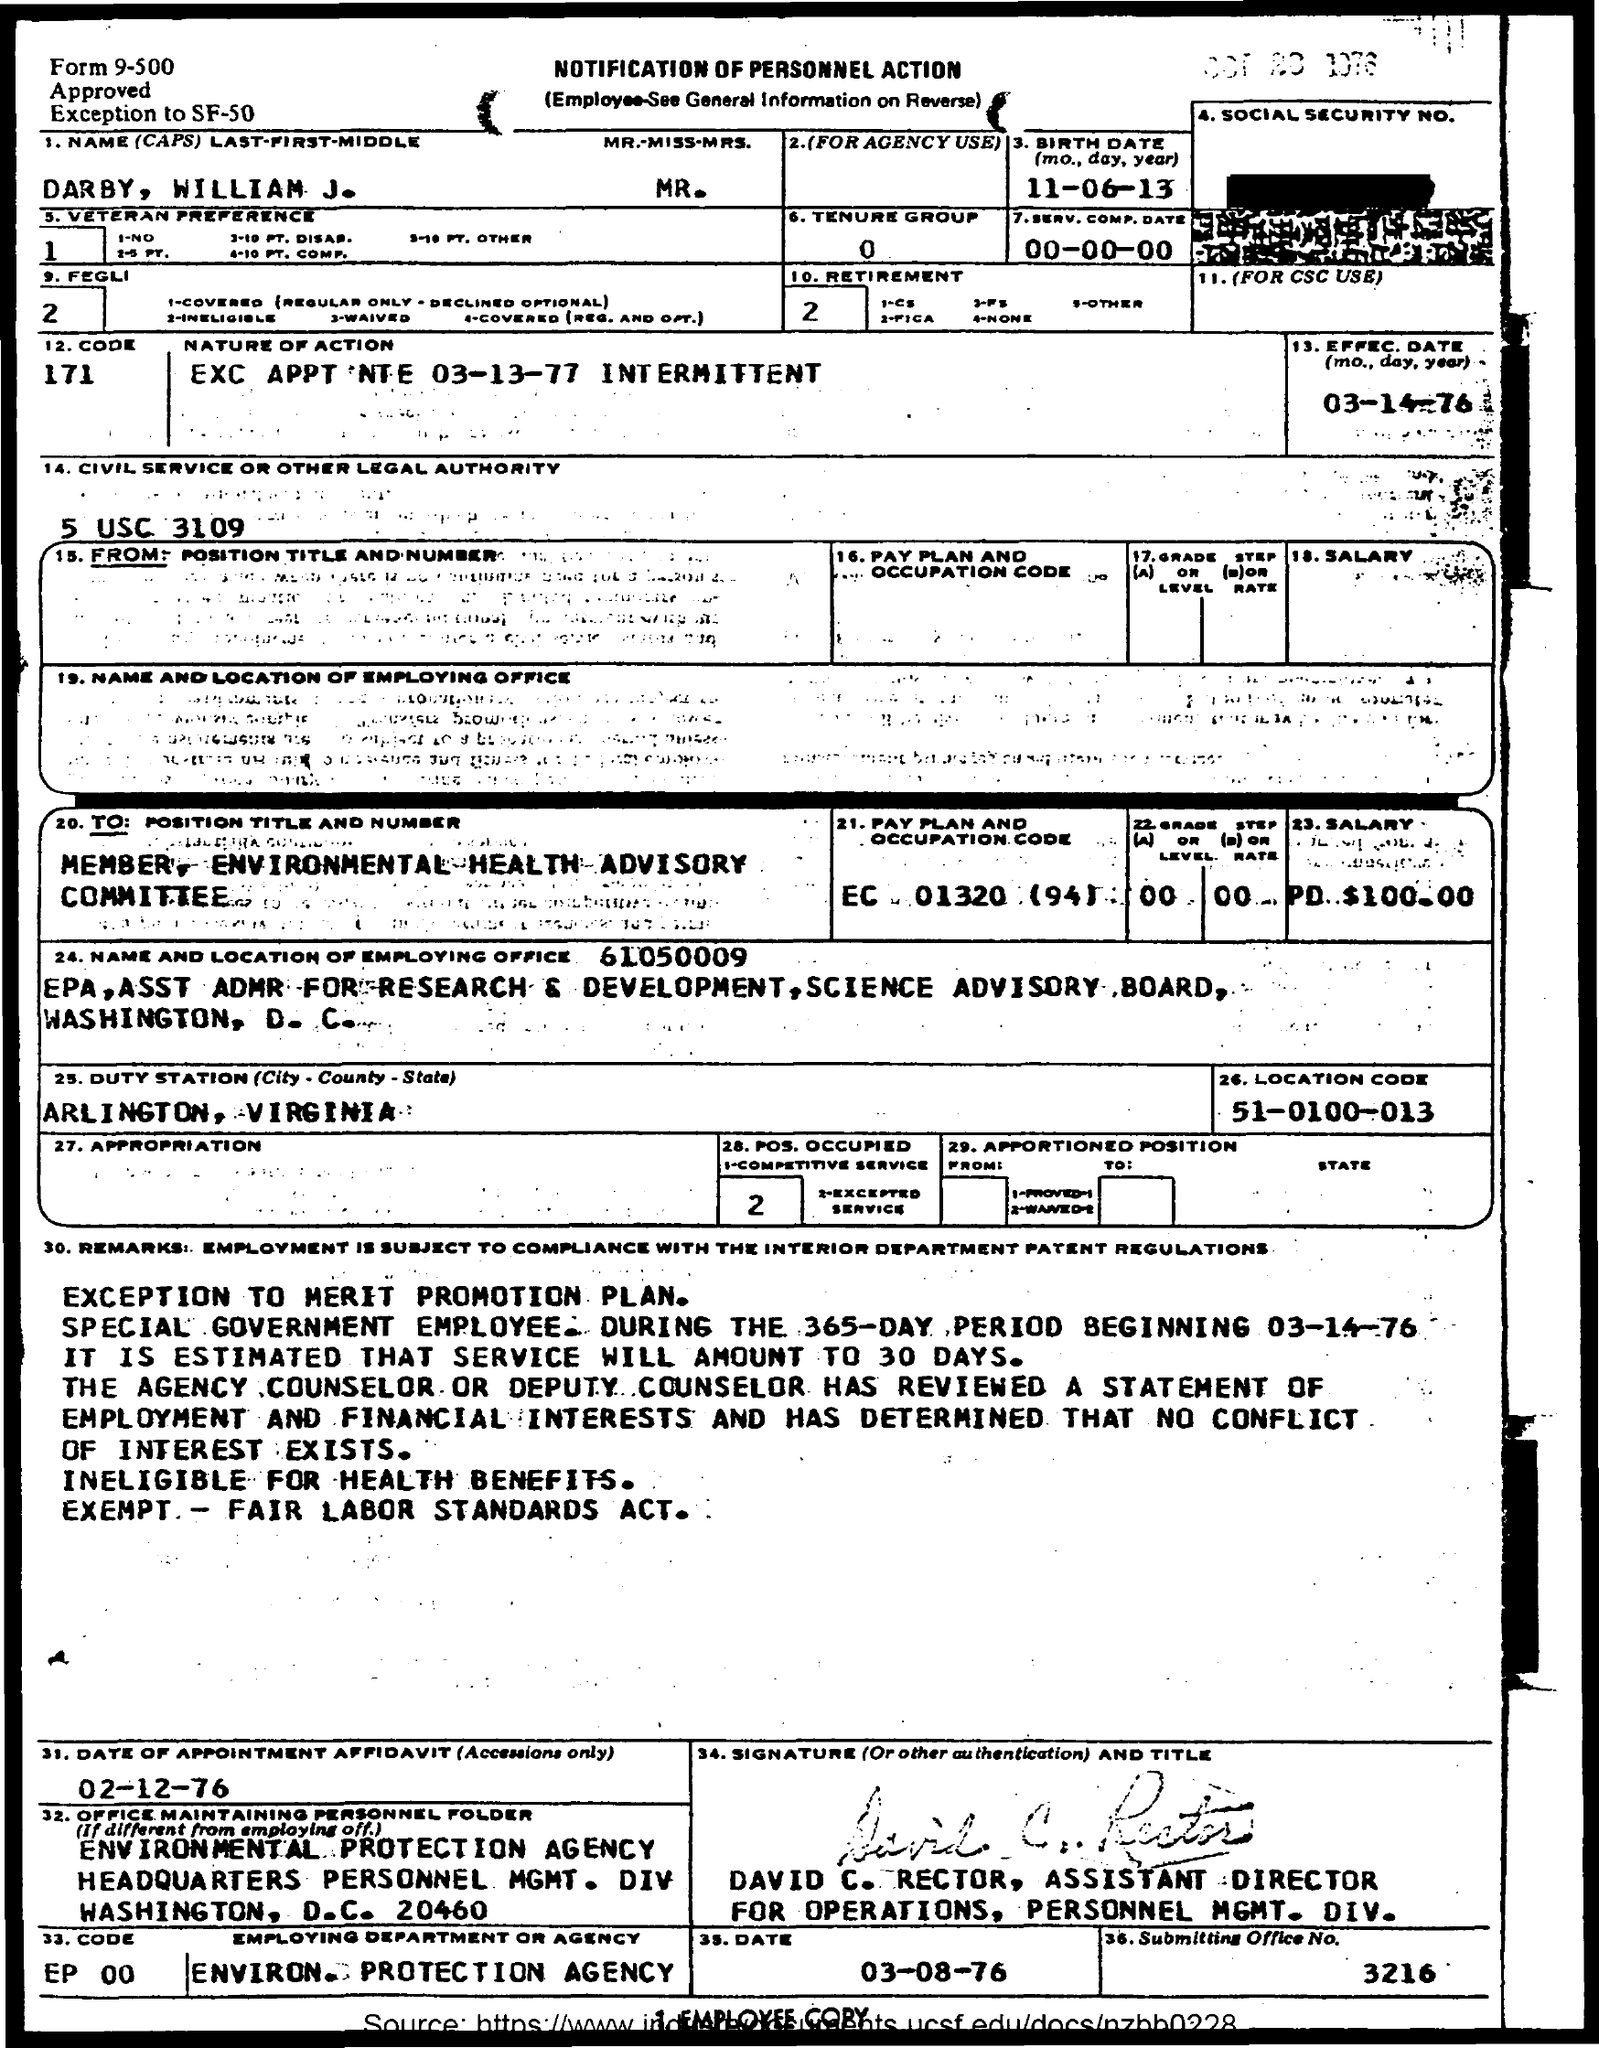What is the location code?
Your response must be concise. 51-0100-013. What is the birth date?
Offer a very short reply. 11-06-13. 